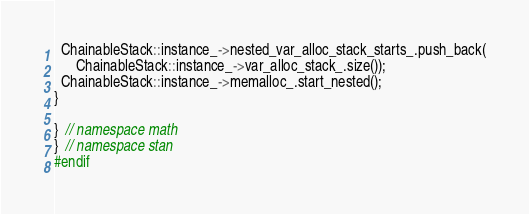<code> <loc_0><loc_0><loc_500><loc_500><_C++_>  ChainableStack::instance_->nested_var_alloc_stack_starts_.push_back(
      ChainableStack::instance_->var_alloc_stack_.size());
  ChainableStack::instance_->memalloc_.start_nested();
}

}  // namespace math
}  // namespace stan
#endif
</code> 